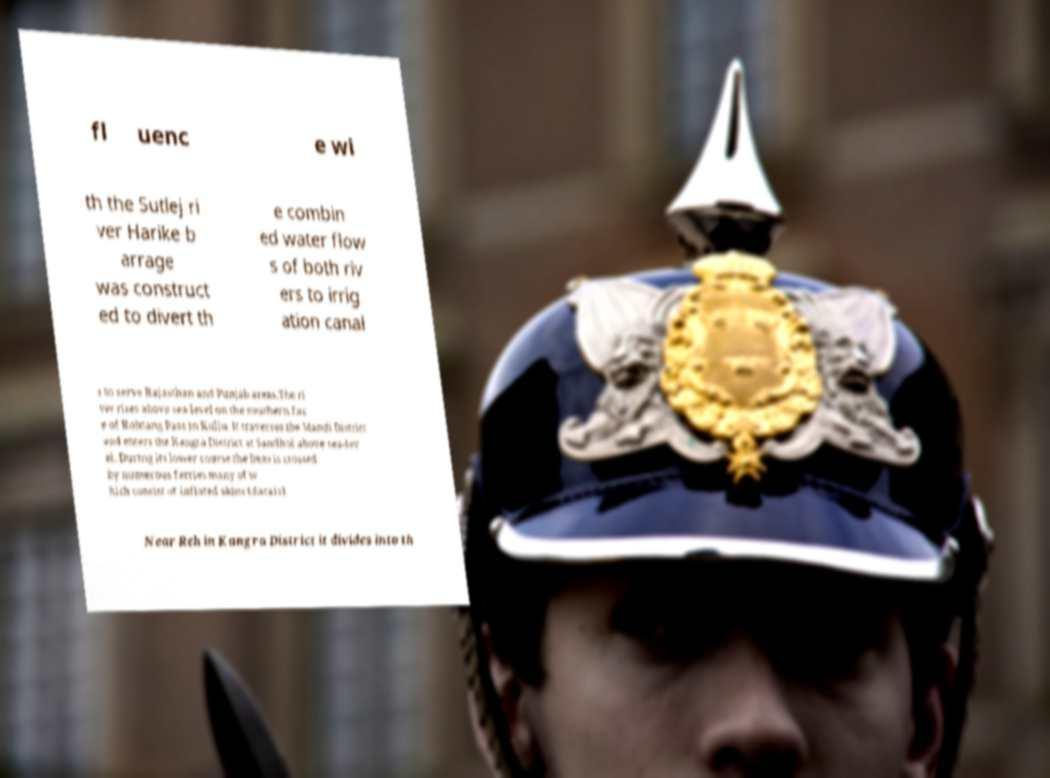What messages or text are displayed in this image? I need them in a readable, typed format. fl uenc e wi th the Sutlej ri ver Harike b arrage was construct ed to divert th e combin ed water flow s of both riv ers to irrig ation canal s to serve Rajasthan and Punjab areas.The ri ver rises above sea-level on the southern fac e of Rohtang Pass in Kullu. It traverses the Mandi District and enters the Kangra District at Sandhol above sea-lev el. During its lower course the Beas is crossed by numerous ferries many of w hich consist of inflated skins (darais). Near Reh in Kangra District it divides into th 